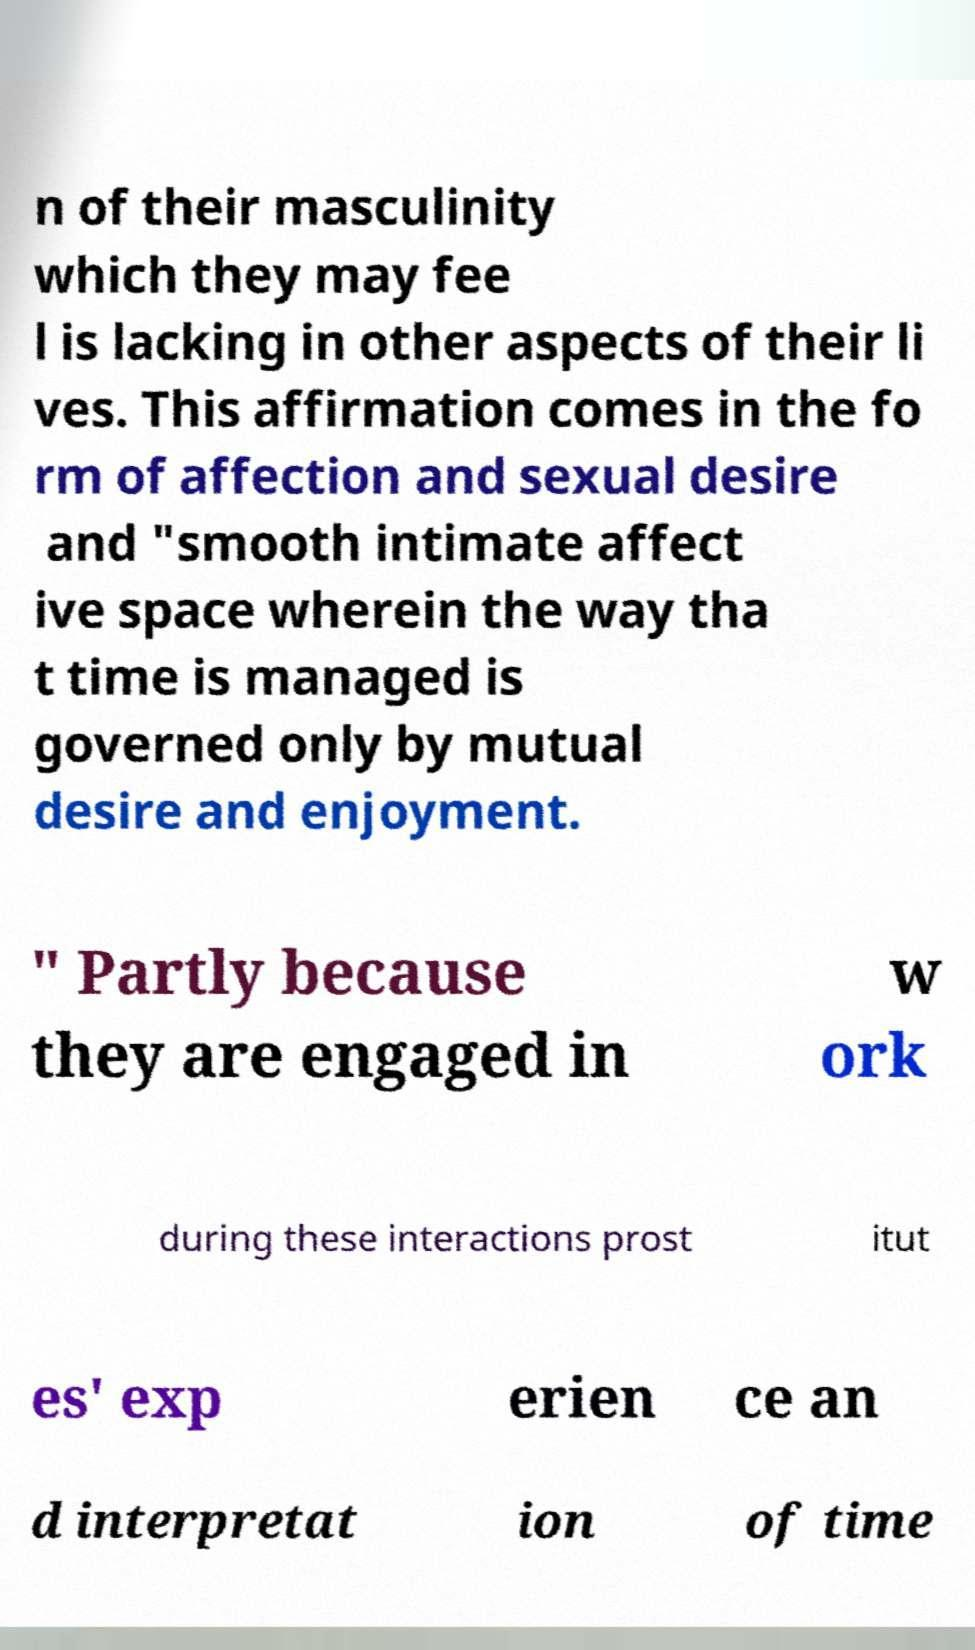Can you read and provide the text displayed in the image?This photo seems to have some interesting text. Can you extract and type it out for me? n of their masculinity which they may fee l is lacking in other aspects of their li ves. This affirmation comes in the fo rm of affection and sexual desire and "smooth intimate affect ive space wherein the way tha t time is managed is governed only by mutual desire and enjoyment. " Partly because they are engaged in w ork during these interactions prost itut es' exp erien ce an d interpretat ion of time 